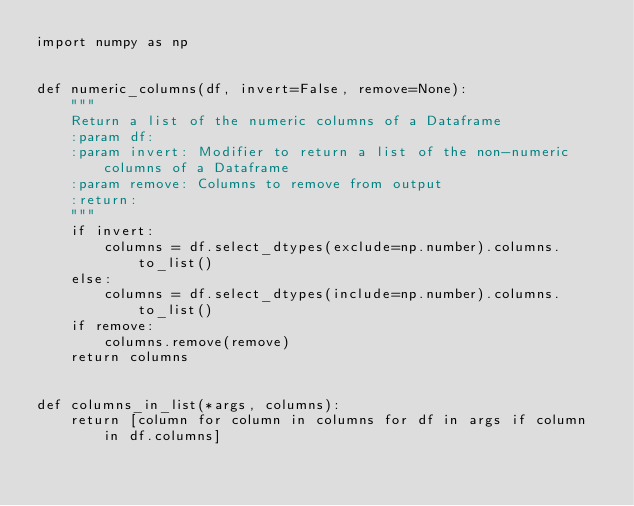Convert code to text. <code><loc_0><loc_0><loc_500><loc_500><_Python_>import numpy as np


def numeric_columns(df, invert=False, remove=None):
    """
    Return a list of the numeric columns of a Dataframe
    :param df:
    :param invert: Modifier to return a list of the non-numeric columns of a Dataframe
    :param remove: Columns to remove from output
    :return:
    """
    if invert:
        columns = df.select_dtypes(exclude=np.number).columns.to_list()
    else:
        columns = df.select_dtypes(include=np.number).columns.to_list()
    if remove:
        columns.remove(remove)
    return columns


def columns_in_list(*args, columns):
    return [column for column in columns for df in args if column in df.columns]
</code> 